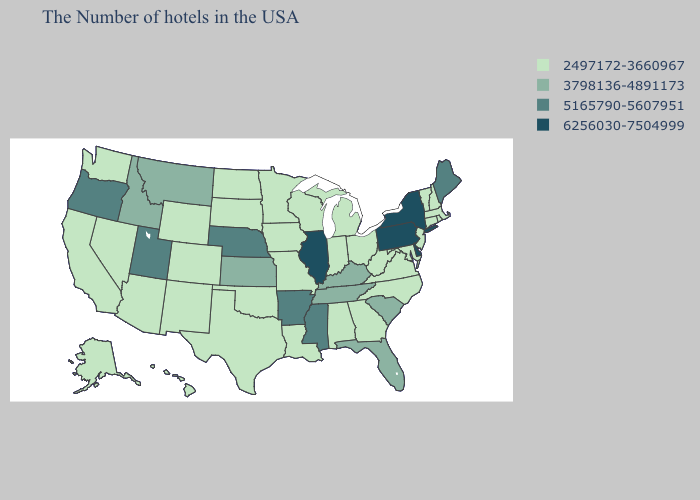Which states have the lowest value in the MidWest?
Give a very brief answer. Ohio, Michigan, Indiana, Wisconsin, Missouri, Minnesota, Iowa, South Dakota, North Dakota. Does Minnesota have a lower value than Georgia?
Answer briefly. No. What is the lowest value in the MidWest?
Keep it brief. 2497172-3660967. Does South Dakota have the same value as New Hampshire?
Quick response, please. Yes. What is the value of Nevada?
Concise answer only. 2497172-3660967. What is the highest value in the West ?
Answer briefly. 5165790-5607951. What is the value of Minnesota?
Write a very short answer. 2497172-3660967. Is the legend a continuous bar?
Quick response, please. No. Name the states that have a value in the range 3798136-4891173?
Give a very brief answer. South Carolina, Florida, Kentucky, Tennessee, Kansas, Montana, Idaho. Which states hav the highest value in the MidWest?
Give a very brief answer. Illinois. Which states hav the highest value in the Northeast?
Quick response, please. New York, Pennsylvania. What is the value of Virginia?
Keep it brief. 2497172-3660967. What is the highest value in the MidWest ?
Answer briefly. 6256030-7504999. Among the states that border Virginia , does Maryland have the highest value?
Give a very brief answer. No. Name the states that have a value in the range 5165790-5607951?
Give a very brief answer. Maine, Mississippi, Arkansas, Nebraska, Utah, Oregon. 